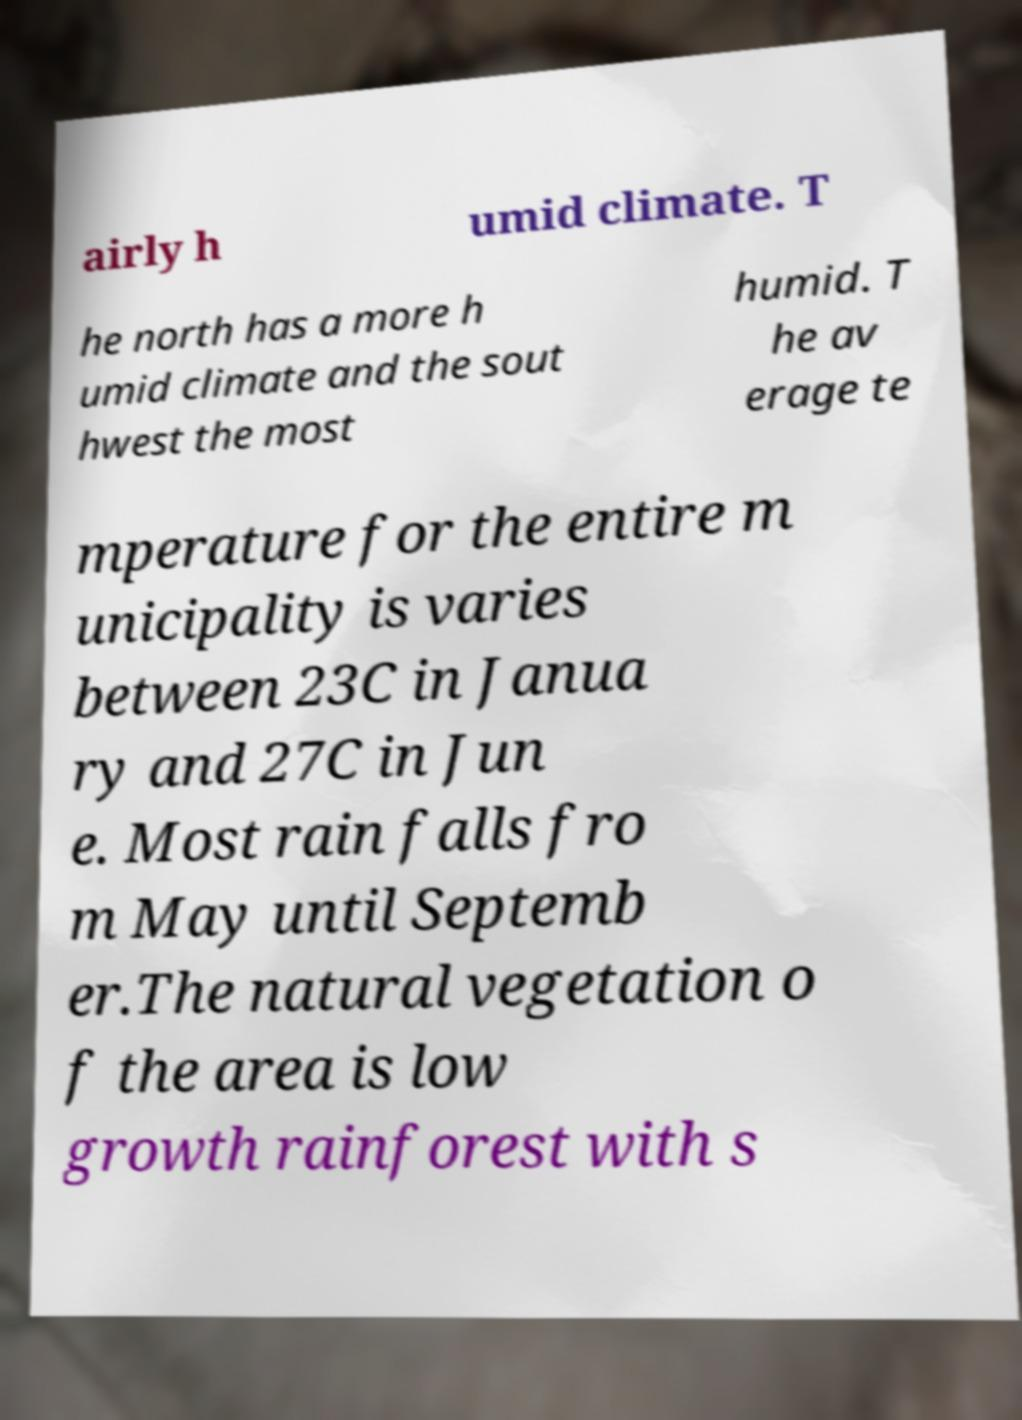I need the written content from this picture converted into text. Can you do that? airly h umid climate. T he north has a more h umid climate and the sout hwest the most humid. T he av erage te mperature for the entire m unicipality is varies between 23C in Janua ry and 27C in Jun e. Most rain falls fro m May until Septemb er.The natural vegetation o f the area is low growth rainforest with s 